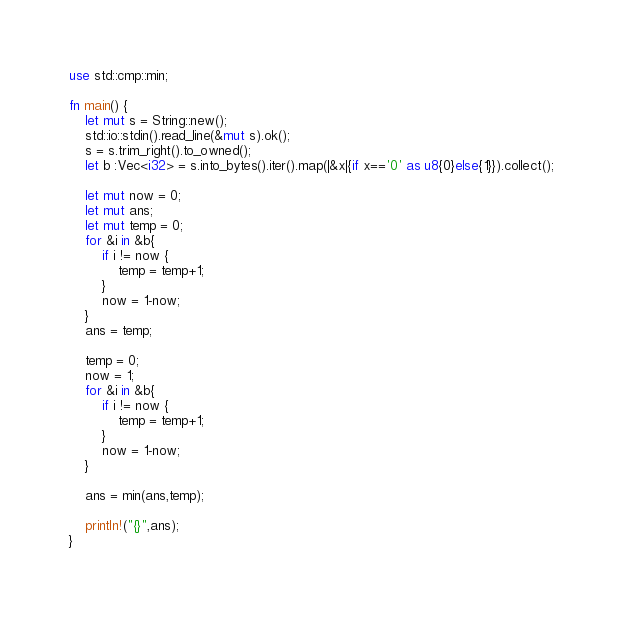<code> <loc_0><loc_0><loc_500><loc_500><_Rust_>use std::cmp::min;

fn main() {
    let mut s = String::new();
    std::io::stdin().read_line(&mut s).ok();
    s = s.trim_right().to_owned();
    let b :Vec<i32> = s.into_bytes().iter().map(|&x|{if x=='0' as u8{0}else{1}}).collect();

    let mut now = 0;
    let mut ans;
    let mut temp = 0;
    for &i in &b{
        if i != now {
            temp = temp+1;
        }
        now = 1-now;
    }
    ans = temp;

    temp = 0;
    now = 1;
    for &i in &b{
        if i != now {
            temp = temp+1;
        }
        now = 1-now;
    }

    ans = min(ans,temp);

    println!("{}",ans);
}
</code> 